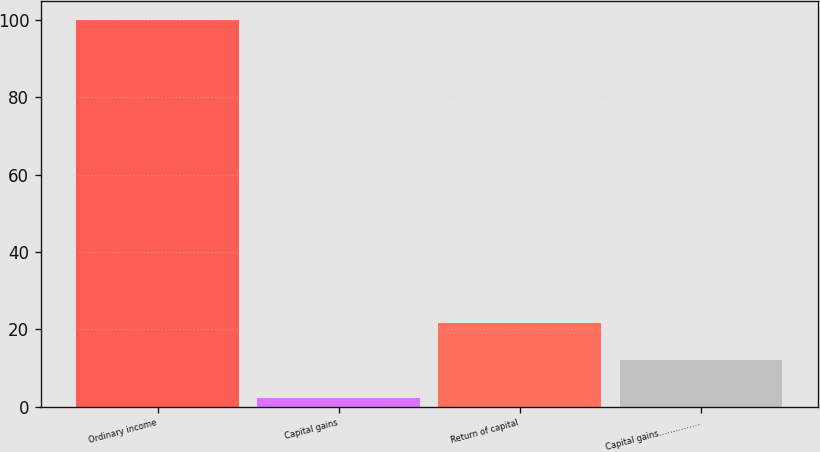<chart> <loc_0><loc_0><loc_500><loc_500><bar_chart><fcel>Ordinary income<fcel>Capital gains<fcel>Return of capital<fcel>Capital gains……………<nl><fcel>100<fcel>2.14<fcel>21.72<fcel>11.93<nl></chart> 